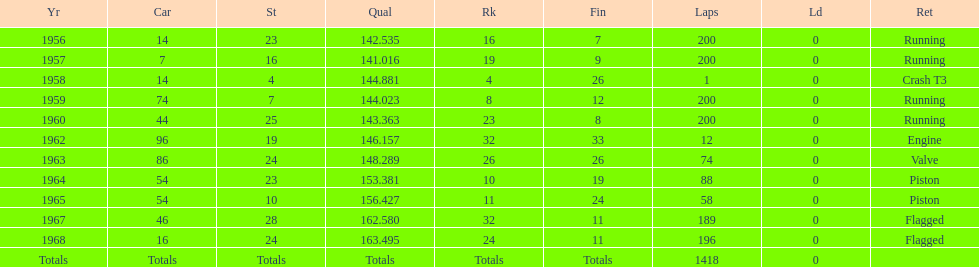What was the last year that it finished the race? 1968. 